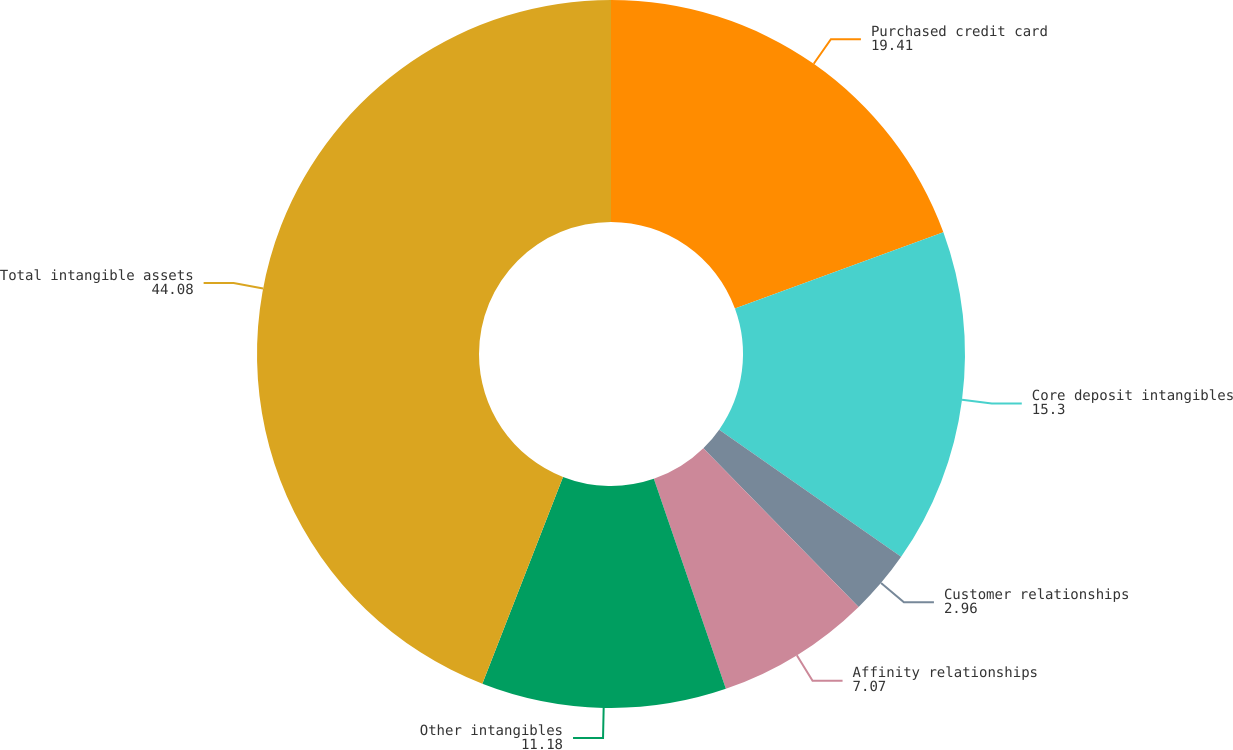<chart> <loc_0><loc_0><loc_500><loc_500><pie_chart><fcel>Purchased credit card<fcel>Core deposit intangibles<fcel>Customer relationships<fcel>Affinity relationships<fcel>Other intangibles<fcel>Total intangible assets<nl><fcel>19.41%<fcel>15.3%<fcel>2.96%<fcel>7.07%<fcel>11.18%<fcel>44.08%<nl></chart> 